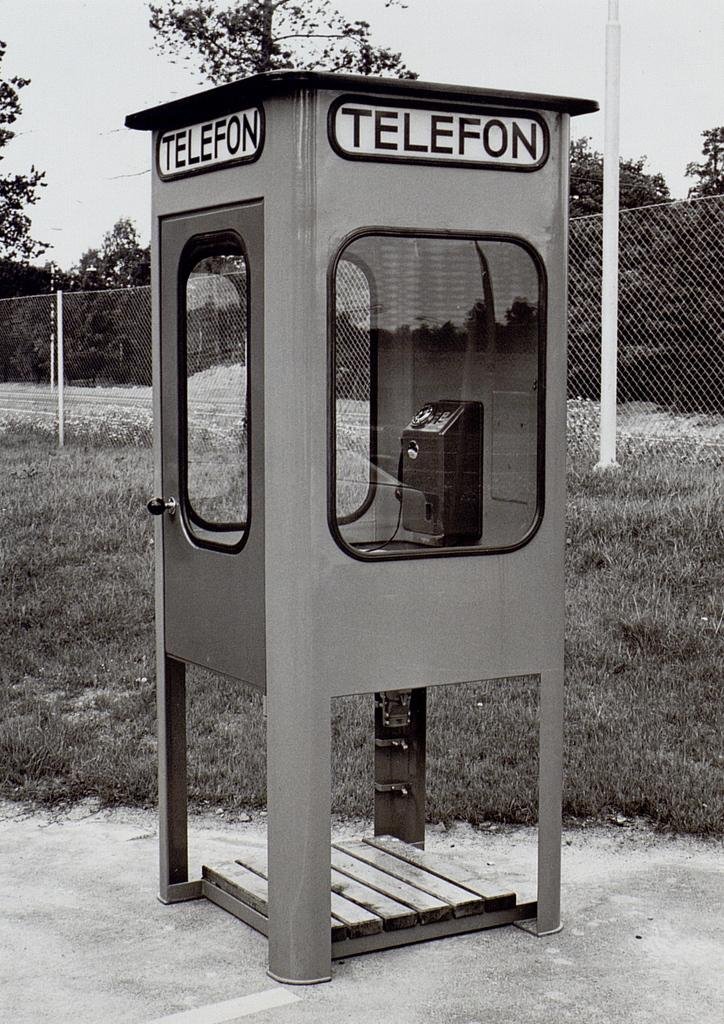<image>
Create a compact narrative representing the image presented. An old phone booth with the word, 'Telefon', is in front of a wire fence. 